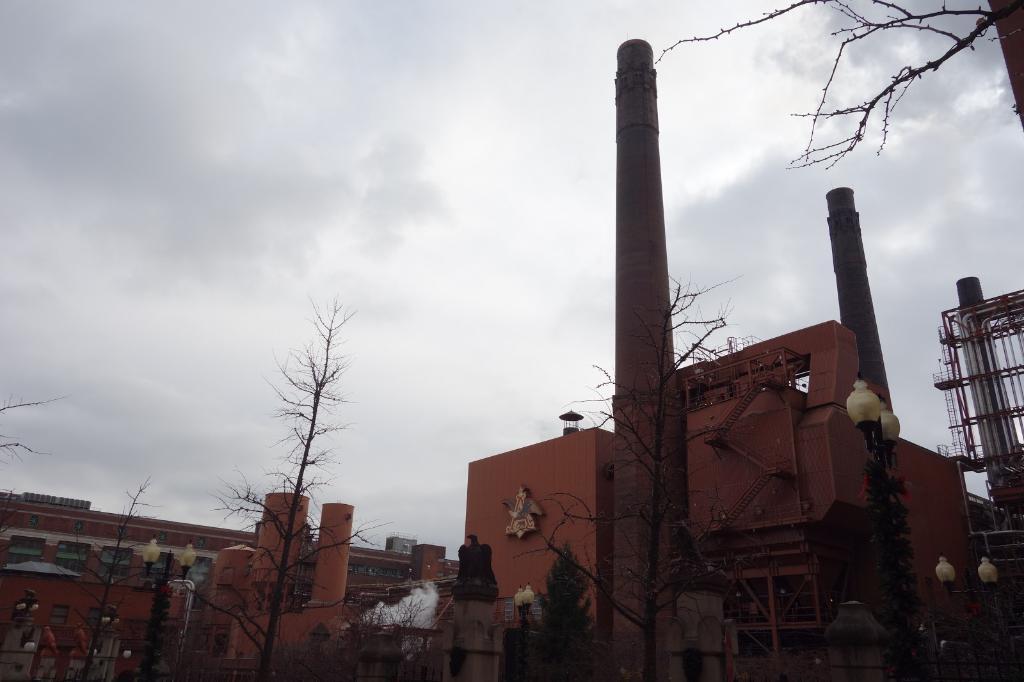Describe this image in one or two sentences. At the bottom of the picture, we see trees and the street lights. There are buildings in the background. These buildings are in brown color. At the top of the picture, we see the sky. 